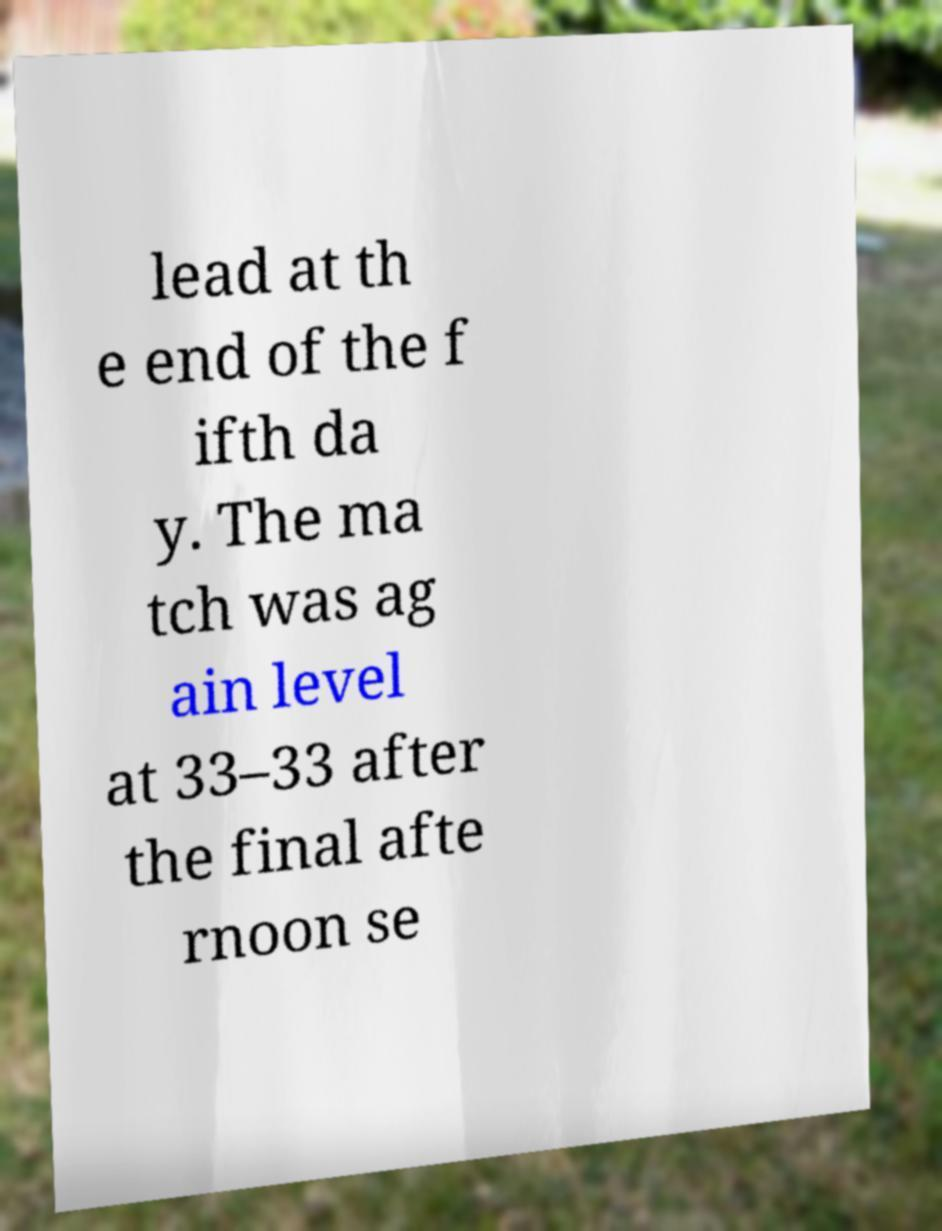Please identify and transcribe the text found in this image. lead at th e end of the f ifth da y. The ma tch was ag ain level at 33–33 after the final afte rnoon se 